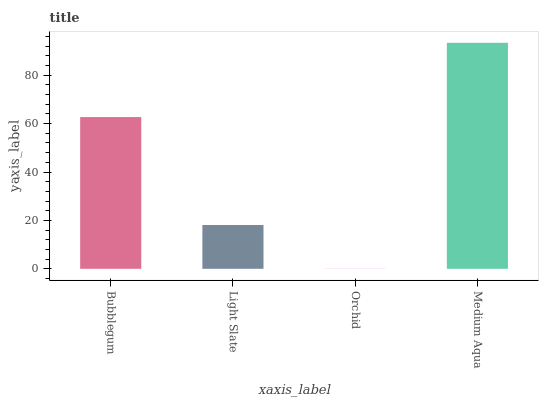Is Orchid the minimum?
Answer yes or no. Yes. Is Medium Aqua the maximum?
Answer yes or no. Yes. Is Light Slate the minimum?
Answer yes or no. No. Is Light Slate the maximum?
Answer yes or no. No. Is Bubblegum greater than Light Slate?
Answer yes or no. Yes. Is Light Slate less than Bubblegum?
Answer yes or no. Yes. Is Light Slate greater than Bubblegum?
Answer yes or no. No. Is Bubblegum less than Light Slate?
Answer yes or no. No. Is Bubblegum the high median?
Answer yes or no. Yes. Is Light Slate the low median?
Answer yes or no. Yes. Is Orchid the high median?
Answer yes or no. No. Is Medium Aqua the low median?
Answer yes or no. No. 